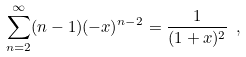Convert formula to latex. <formula><loc_0><loc_0><loc_500><loc_500>\sum _ { n = 2 } ^ { \infty } ( n - 1 ) ( - x ) ^ { n - 2 } = \frac { 1 } { ( 1 + x ) ^ { 2 } } \ ,</formula> 